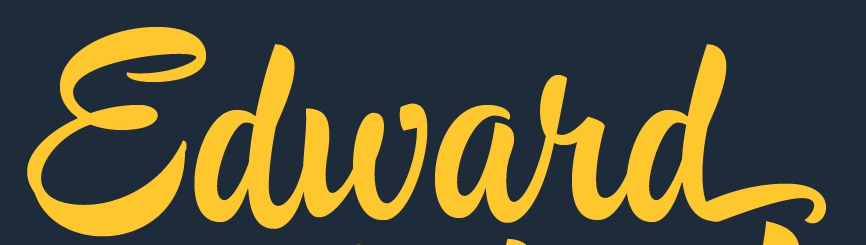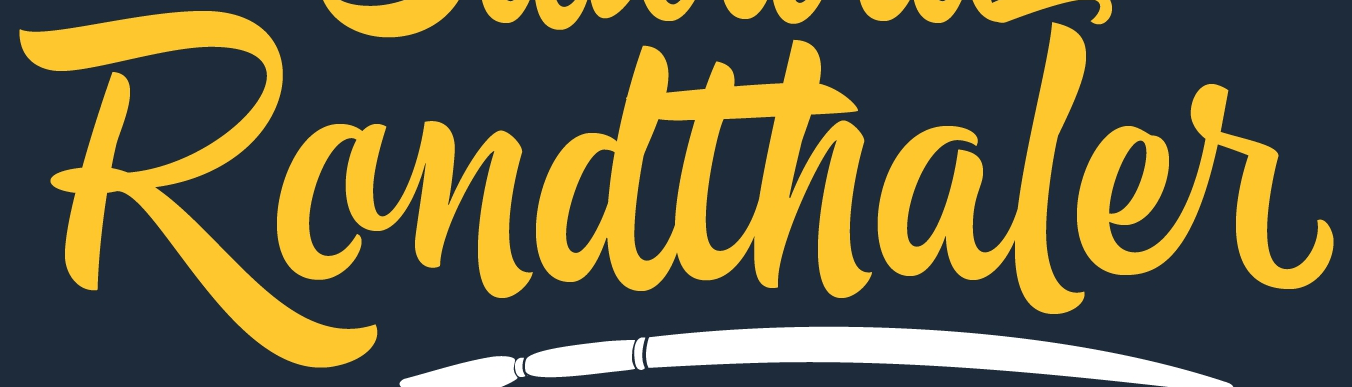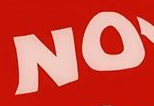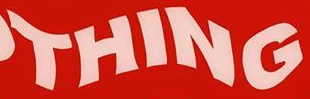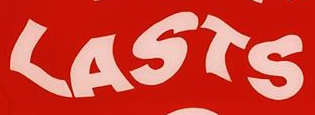Read the text from these images in sequence, separated by a semicolon. Edward; Randthaler; NO; THING; LASTS 